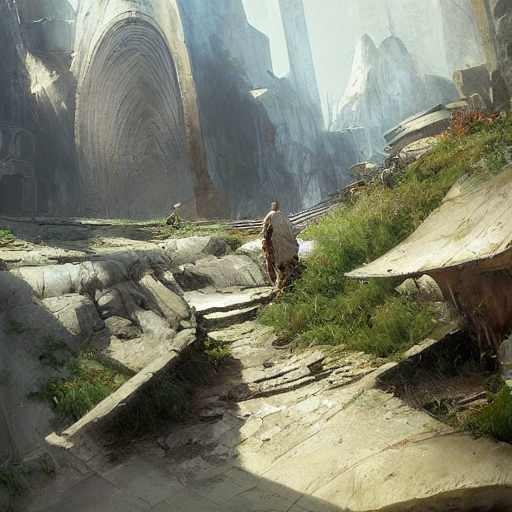Are there any quality issues with this image? While the previous response was simply affirmative, to be more precise, the image does not exhibit any discernible quality issues. It features a person walking through a landscape with towering rock formations and ruins, and the artwork is detailed with good resolution, dynamic range, and composition. 